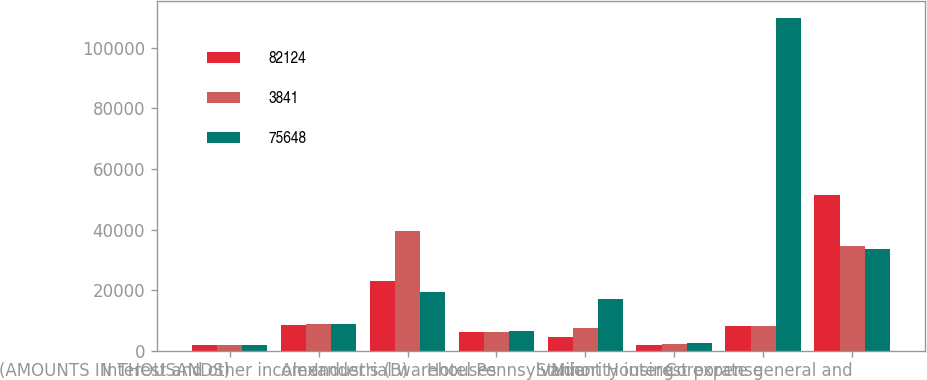Convert chart. <chart><loc_0><loc_0><loc_500><loc_500><stacked_bar_chart><ecel><fcel>(AMOUNTS IN THOUSANDS)<fcel>Interest and other income<fcel>Alexander's (B)<fcel>Industrial warehouses<fcel>Hotel Pennsylvania<fcel>Student Housing<fcel>Minority interest expense<fcel>Corporate general and<nl><fcel>82124<fcel>2003<fcel>8532<fcel>23001<fcel>6208<fcel>4573<fcel>2000<fcel>8084<fcel>51461<nl><fcel>3841<fcel>2002<fcel>8795<fcel>39436<fcel>6223<fcel>7636<fcel>2340<fcel>8084<fcel>34743<nl><fcel>75648<fcel>2001<fcel>8700<fcel>19362<fcel>6639<fcel>16978<fcel>2428<fcel>109897<fcel>33515<nl></chart> 